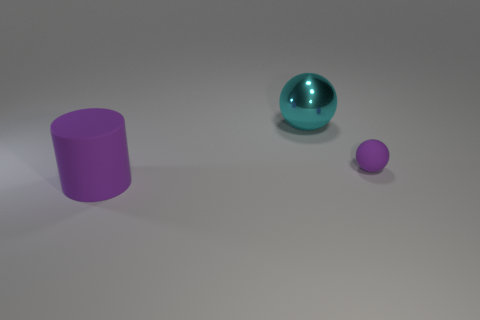Add 2 blue matte things. How many objects exist? 5 Subtract all balls. How many objects are left? 1 Add 2 large cylinders. How many large cylinders are left? 3 Add 2 cyan objects. How many cyan objects exist? 3 Subtract 1 cyan balls. How many objects are left? 2 Subtract all tiny red rubber cylinders. Subtract all large purple rubber cylinders. How many objects are left? 2 